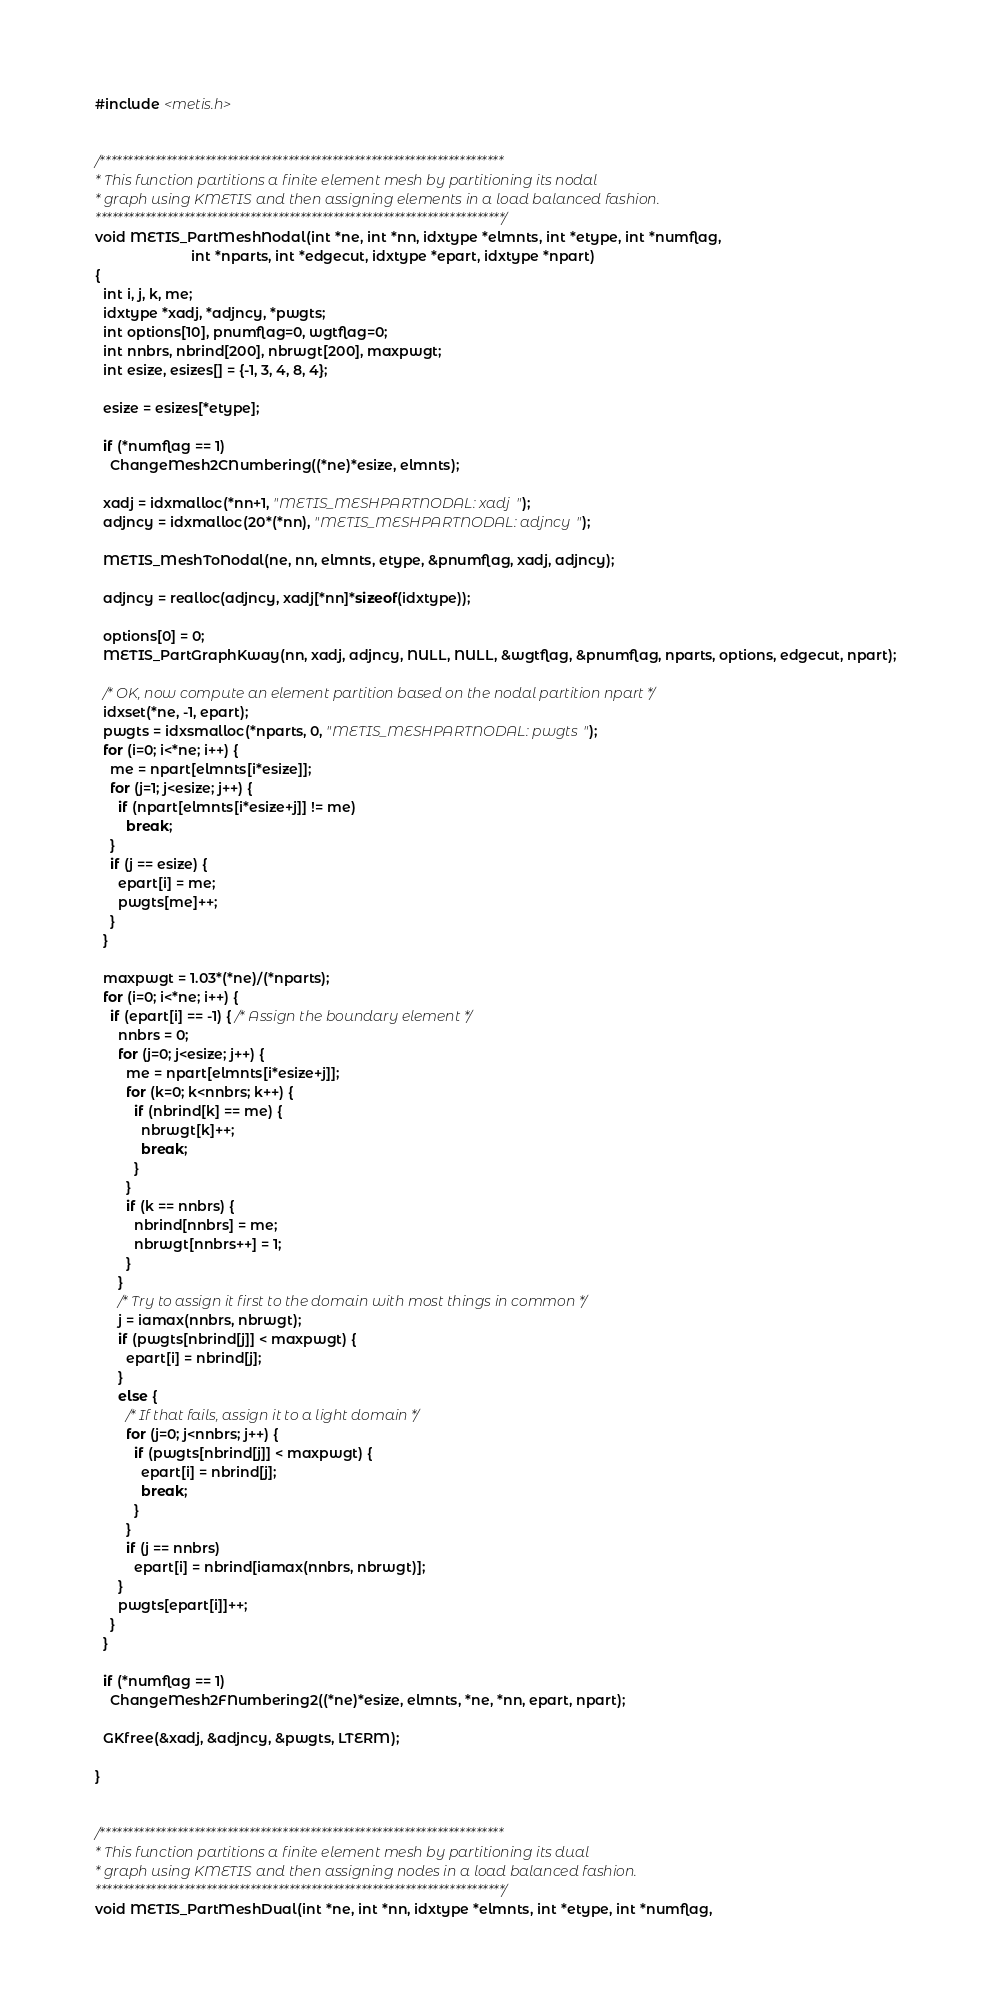Convert code to text. <code><loc_0><loc_0><loc_500><loc_500><_C_>
#include <metis.h>


/*************************************************************************
* This function partitions a finite element mesh by partitioning its nodal
* graph using KMETIS and then assigning elements in a load balanced fashion.
**************************************************************************/
void METIS_PartMeshNodal(int *ne, int *nn, idxtype *elmnts, int *etype, int *numflag, 
                         int *nparts, int *edgecut, idxtype *epart, idxtype *npart)
{
  int i, j, k, me;
  idxtype *xadj, *adjncy, *pwgts;
  int options[10], pnumflag=0, wgtflag=0;
  int nnbrs, nbrind[200], nbrwgt[200], maxpwgt;
  int esize, esizes[] = {-1, 3, 4, 8, 4};

  esize = esizes[*etype];

  if (*numflag == 1)
    ChangeMesh2CNumbering((*ne)*esize, elmnts);

  xadj = idxmalloc(*nn+1, "METIS_MESHPARTNODAL: xadj");
  adjncy = idxmalloc(20*(*nn), "METIS_MESHPARTNODAL: adjncy");

  METIS_MeshToNodal(ne, nn, elmnts, etype, &pnumflag, xadj, adjncy);

  adjncy = realloc(adjncy, xadj[*nn]*sizeof(idxtype));

  options[0] = 0;
  METIS_PartGraphKway(nn, xadj, adjncy, NULL, NULL, &wgtflag, &pnumflag, nparts, options, edgecut, npart);

  /* OK, now compute an element partition based on the nodal partition npart */
  idxset(*ne, -1, epart);
  pwgts = idxsmalloc(*nparts, 0, "METIS_MESHPARTNODAL: pwgts");
  for (i=0; i<*ne; i++) {
    me = npart[elmnts[i*esize]];
    for (j=1; j<esize; j++) {
      if (npart[elmnts[i*esize+j]] != me)
        break;
    }
    if (j == esize) {
      epart[i] = me;
      pwgts[me]++;
    }
  }

  maxpwgt = 1.03*(*ne)/(*nparts);
  for (i=0; i<*ne; i++) {
    if (epart[i] == -1) { /* Assign the boundary element */
      nnbrs = 0;
      for (j=0; j<esize; j++) {
        me = npart[elmnts[i*esize+j]];
        for (k=0; k<nnbrs; k++) {
          if (nbrind[k] == me) {
            nbrwgt[k]++;
            break;
          }
        }
        if (k == nnbrs) {
          nbrind[nnbrs] = me;
          nbrwgt[nnbrs++] = 1;
        }
      }
      /* Try to assign it first to the domain with most things in common */
      j = iamax(nnbrs, nbrwgt);
      if (pwgts[nbrind[j]] < maxpwgt) {
        epart[i] = nbrind[j];
      }
      else {
        /* If that fails, assign it to a light domain */
        for (j=0; j<nnbrs; j++) {
          if (pwgts[nbrind[j]] < maxpwgt) {
            epart[i] = nbrind[j];
            break;
          }
        }
        if (j == nnbrs) 
          epart[i] = nbrind[iamax(nnbrs, nbrwgt)];
      }
      pwgts[epart[i]]++;
    }
  }

  if (*numflag == 1)
    ChangeMesh2FNumbering2((*ne)*esize, elmnts, *ne, *nn, epart, npart);

  GKfree(&xadj, &adjncy, &pwgts, LTERM);

}


/*************************************************************************
* This function partitions a finite element mesh by partitioning its dual
* graph using KMETIS and then assigning nodes in a load balanced fashion.
**************************************************************************/
void METIS_PartMeshDual(int *ne, int *nn, idxtype *elmnts, int *etype, int *numflag, </code> 